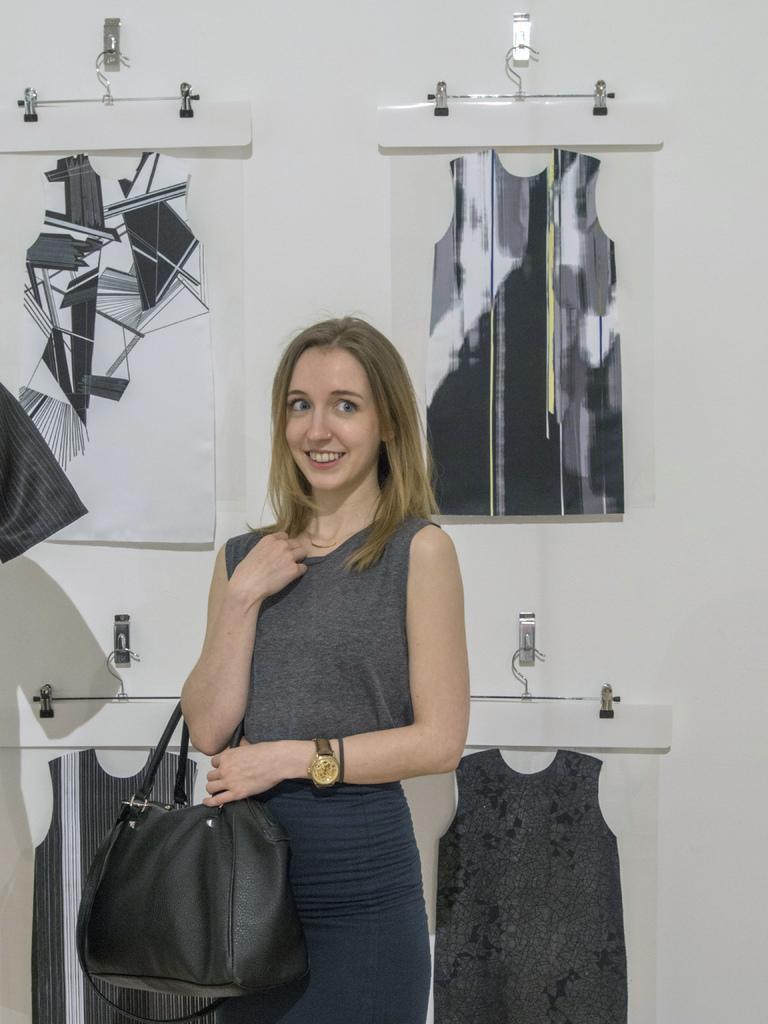Could you give a brief overview of what you see in this image? This picture is of inside the room. In the center there is a woman wearing grey color t-shirt, smiling and wearing a bag and standing. In the background we can see a wall and the t-shirts hanging on the wall. 